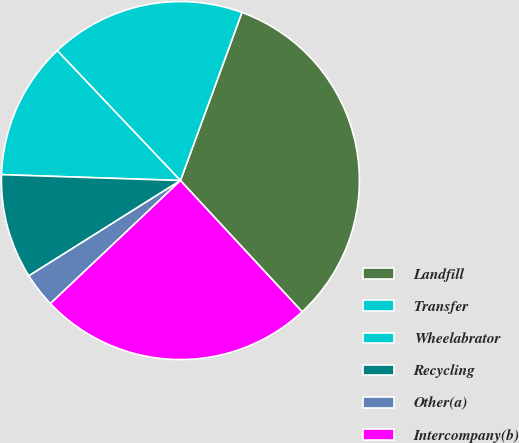Convert chart to OTSL. <chart><loc_0><loc_0><loc_500><loc_500><pie_chart><fcel>Landfill<fcel>Transfer<fcel>Wheelabrator<fcel>Recycling<fcel>Other(a)<fcel>Intercompany(b)<nl><fcel>32.52%<fcel>17.66%<fcel>12.4%<fcel>9.46%<fcel>3.13%<fcel>24.84%<nl></chart> 